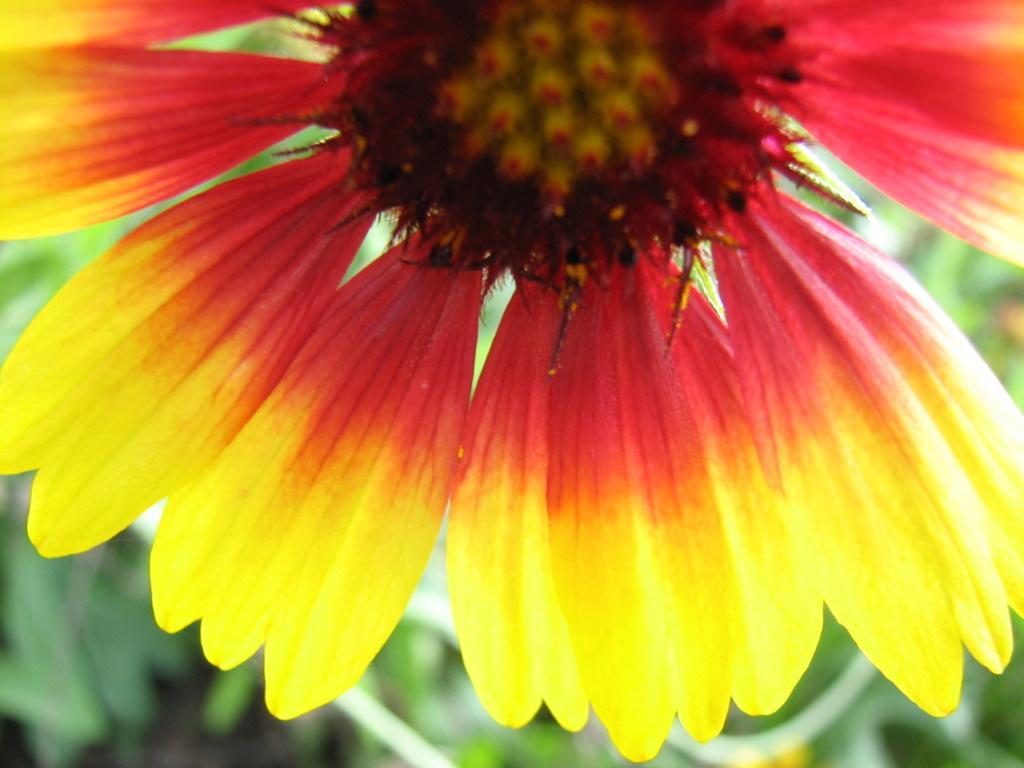Describe this image in one or two sentences. In this picture I can see a flower and few leaves in the background. 